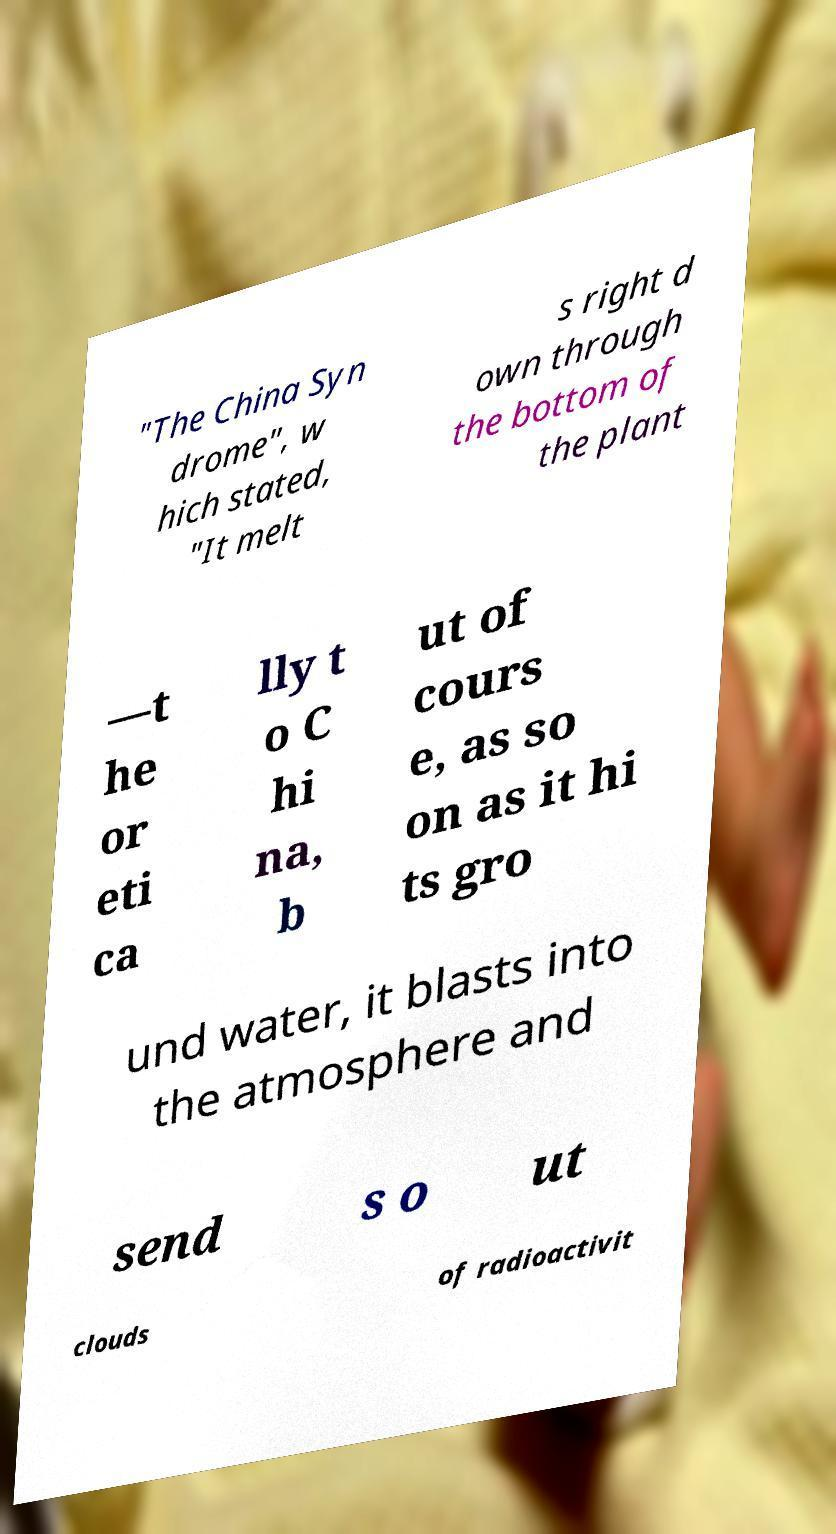Can you read and provide the text displayed in the image?This photo seems to have some interesting text. Can you extract and type it out for me? "The China Syn drome", w hich stated, "It melt s right d own through the bottom of the plant —t he or eti ca lly t o C hi na, b ut of cours e, as so on as it hi ts gro und water, it blasts into the atmosphere and send s o ut clouds of radioactivit 